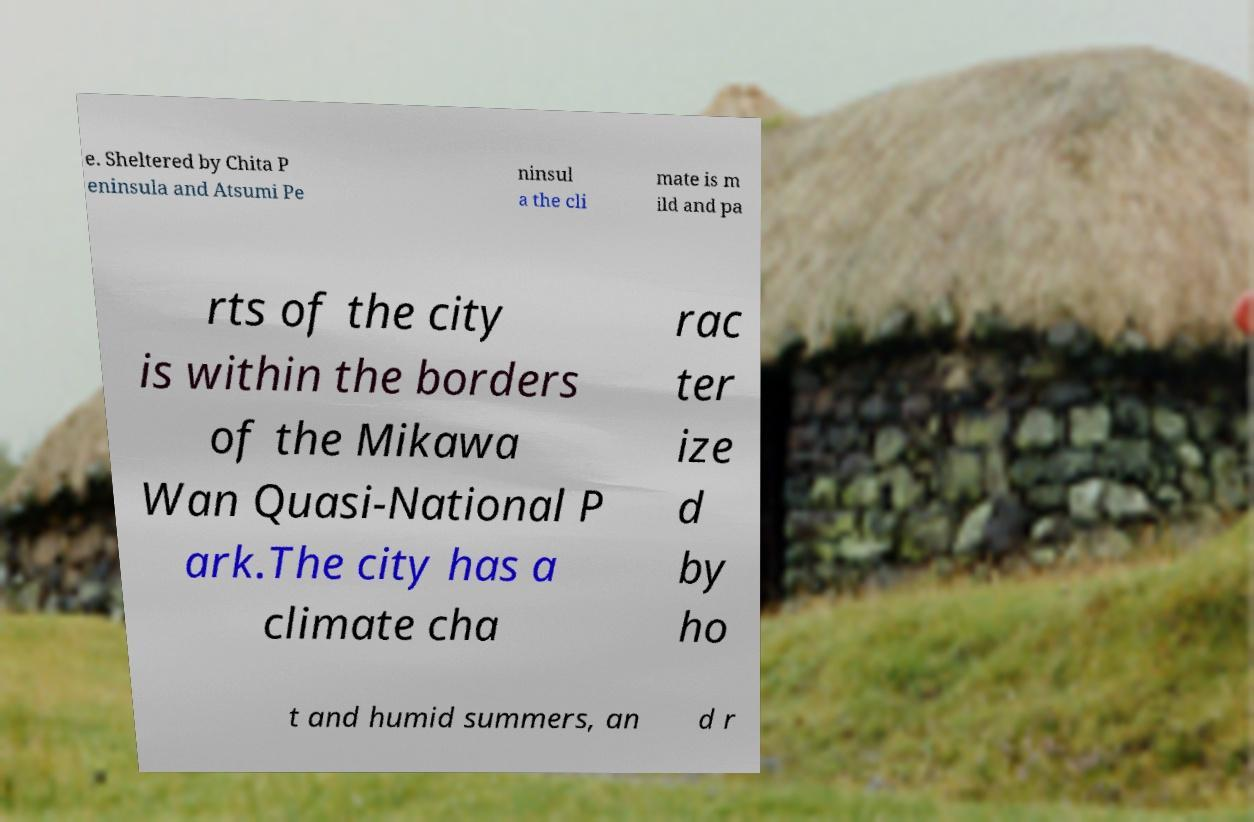I need the written content from this picture converted into text. Can you do that? e. Sheltered by Chita P eninsula and Atsumi Pe ninsul a the cli mate is m ild and pa rts of the city is within the borders of the Mikawa Wan Quasi-National P ark.The city has a climate cha rac ter ize d by ho t and humid summers, an d r 